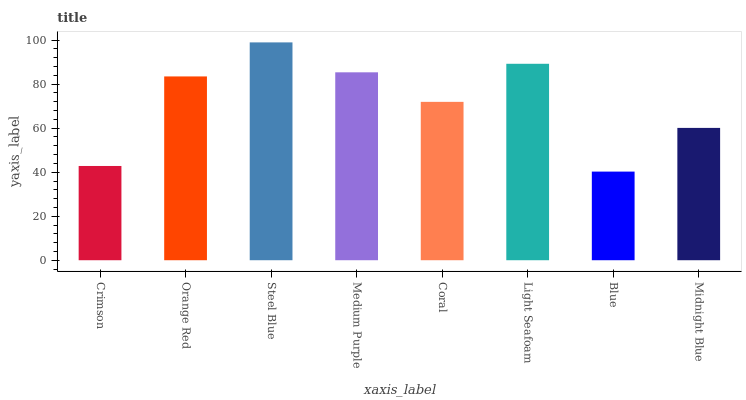Is Blue the minimum?
Answer yes or no. Yes. Is Steel Blue the maximum?
Answer yes or no. Yes. Is Orange Red the minimum?
Answer yes or no. No. Is Orange Red the maximum?
Answer yes or no. No. Is Orange Red greater than Crimson?
Answer yes or no. Yes. Is Crimson less than Orange Red?
Answer yes or no. Yes. Is Crimson greater than Orange Red?
Answer yes or no. No. Is Orange Red less than Crimson?
Answer yes or no. No. Is Orange Red the high median?
Answer yes or no. Yes. Is Coral the low median?
Answer yes or no. Yes. Is Crimson the high median?
Answer yes or no. No. Is Light Seafoam the low median?
Answer yes or no. No. 